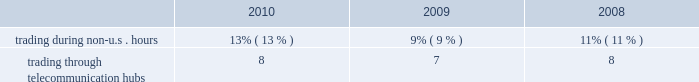Kendal vroman , 39 mr .
Vroman has served as our managing director , commodity products , otc services & information products since february 2010 .
Mr .
Vroman previously served as managing director and chief corporate development officer from 2008 to 2010 .
Mr .
Vroman joined us in 2001 and since then has held positions of increasing responsibility , including most recently as managing director , corporate development and managing director , information and technology services .
Scot e .
Warren , 47 mr .
Warren has served as our managing director , equity index products and index services since february 2010 .
Mr .
Warren previously served as our managing director , equity products since joining us in 2007 .
Prior to that , mr .
Warren worked for goldman sachs as its president , manager trading and business analysis team .
Prior to goldman sachs , mr .
Warren managed equity and option execution and clearing businesses for abn amro in chicago and was a senior consultant for arthur andersen & co .
For financial services firms .
Financial information about geographic areas due to the nature of its business , cme group does not track revenues based upon geographic location .
We do , however , track trading volume generated outside of traditional u.s .
Trading hours and through our international telecommunication hubs .
Our customers can directly access our exchanges throughout the world .
The table shows the percentage of our total trading volume on our globex electronic trading platform generated during non-u.s .
Hours and through our international hubs. .
Available information our web site is www.cmegroup.com .
Information made available on our web site does not constitute part of this document .
We make available on our web site our annual reports on form 10-k , quarterly reports on form 10-q , current reports on form 8-k and amendments to those reports as soon as reasonably practicable after we electronically file or furnish such materials to the sec .
Our corporate governance materials , including our corporate governance principles , director conflict of interest policy , board of directors code of ethics , categorical independence standards , employee code of conduct and the charters for all the standing committees of our board , may also be found on our web site .
Copies of these materials are also available to shareholders free of charge upon written request to shareholder relations and member services , attention ms .
Beth hausoul , cme group inc. , 20 south wacker drive , chicago , illinois 60606. .
What was the increase of trading during non u.s hours between 2009 and 2010? 
Rationale: its the variation between those percentages .
Computations: (13% - 9%)
Answer: 0.04. 